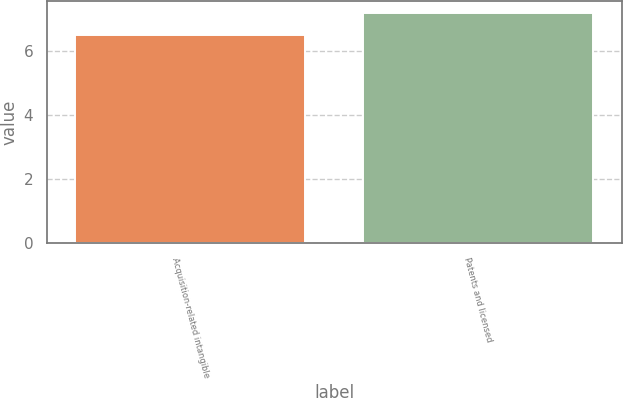<chart> <loc_0><loc_0><loc_500><loc_500><bar_chart><fcel>Acquisition-related intangible<fcel>Patents and licensed<nl><fcel>6.5<fcel>7.2<nl></chart> 